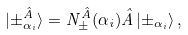Convert formula to latex. <formula><loc_0><loc_0><loc_500><loc_500>| { { \pm _ { \alpha _ { i } } ^ { \hat { A } } } } \rangle = { N _ { \pm } ^ { \hat { A } } ( \alpha _ { i } ) } \hat { A } \left | { \pm _ { \alpha _ { i } } } \right \rangle ,</formula> 